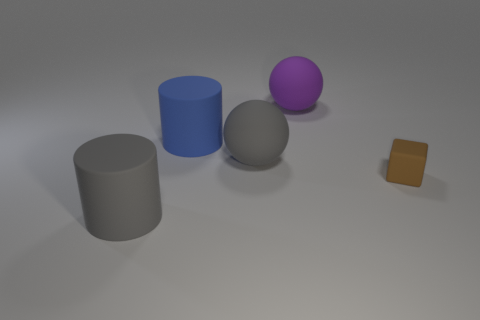Add 1 green metal spheres. How many objects exist? 6 Subtract all cylinders. How many objects are left? 3 Subtract all large purple balls. Subtract all large gray rubber objects. How many objects are left? 2 Add 3 blue rubber objects. How many blue rubber objects are left? 4 Add 2 big red things. How many big red things exist? 2 Subtract 0 cyan balls. How many objects are left? 5 